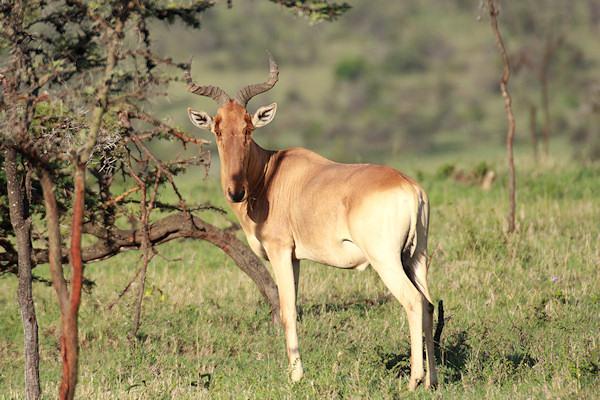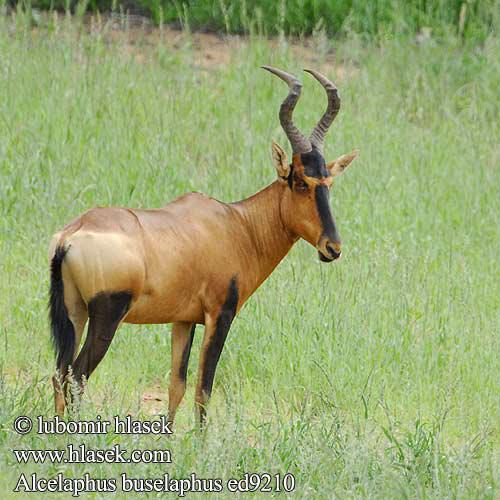The first image is the image on the left, the second image is the image on the right. For the images displayed, is the sentence "A total of three horned animals are shown in grassy areas." factually correct? Answer yes or no. No. 